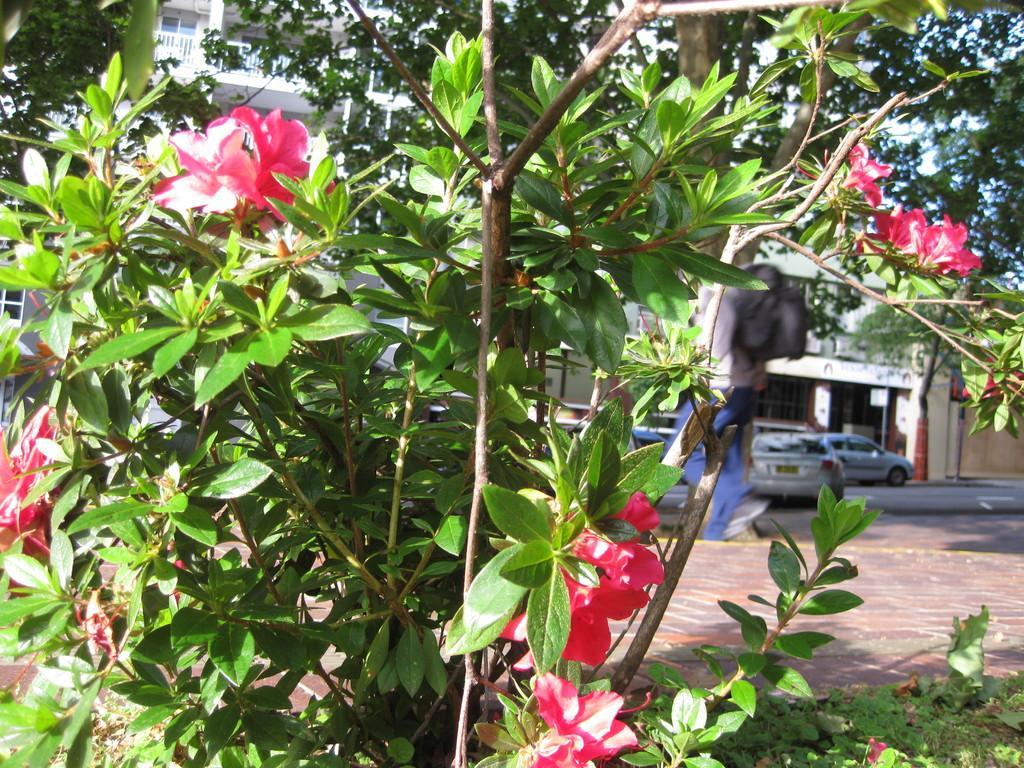Describe this image in one or two sentences. In this image in the front there is a plant with flowers. In the background there are cars and there are buildings. 